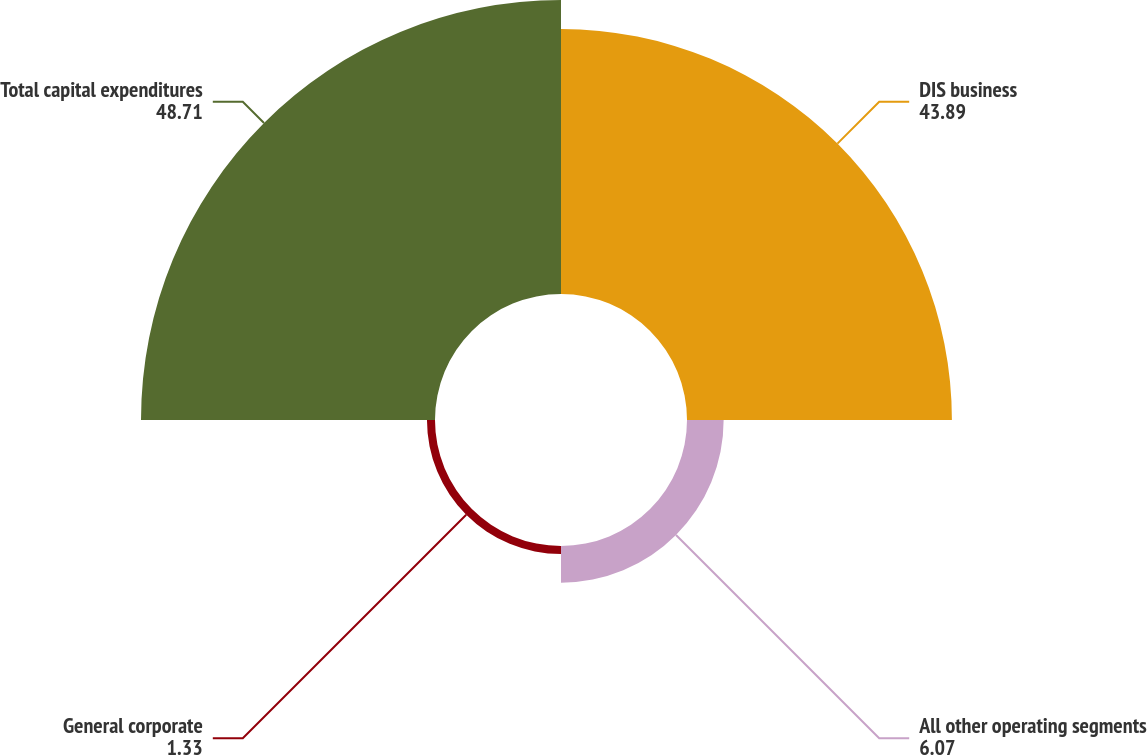Convert chart to OTSL. <chart><loc_0><loc_0><loc_500><loc_500><pie_chart><fcel>DIS business<fcel>All other operating segments<fcel>General corporate<fcel>Total capital expenditures<nl><fcel>43.89%<fcel>6.07%<fcel>1.33%<fcel>48.71%<nl></chart> 